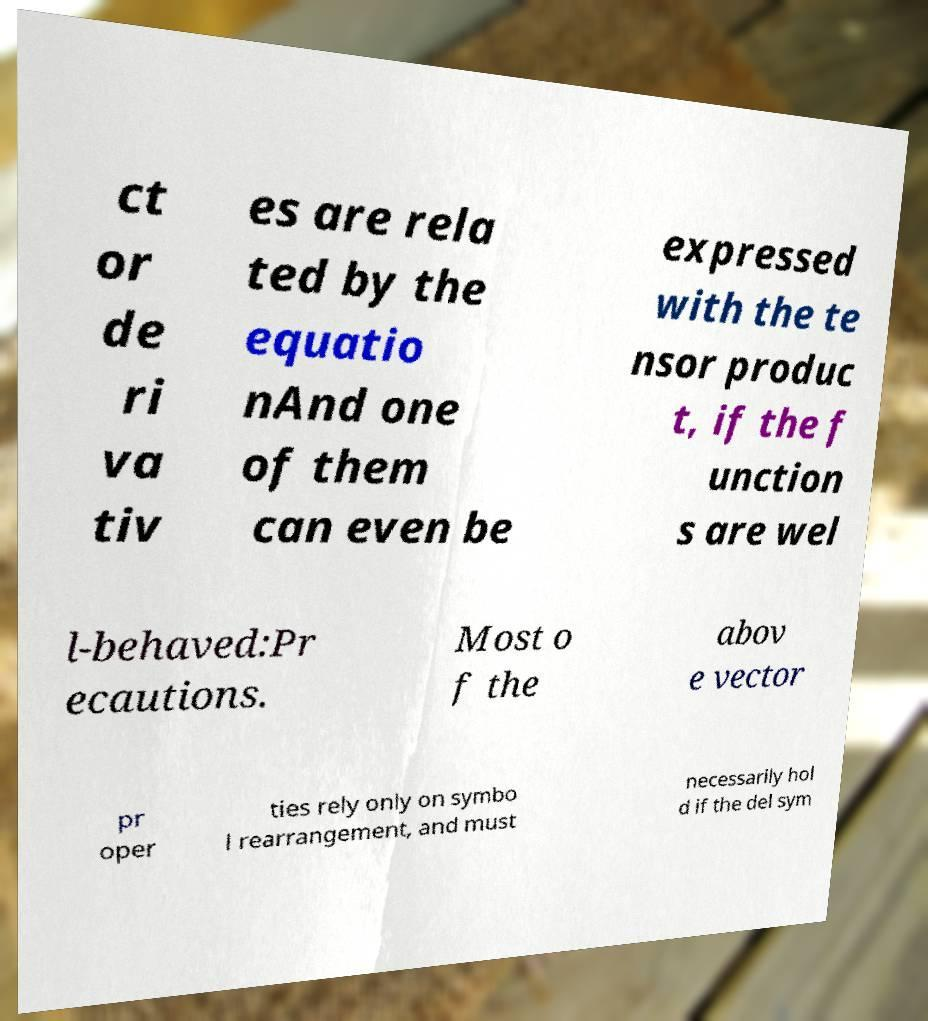Can you read and provide the text displayed in the image?This photo seems to have some interesting text. Can you extract and type it out for me? ct or de ri va tiv es are rela ted by the equatio nAnd one of them can even be expressed with the te nsor produc t, if the f unction s are wel l-behaved:Pr ecautions. Most o f the abov e vector pr oper ties rely only on symbo l rearrangement, and must necessarily hol d if the del sym 